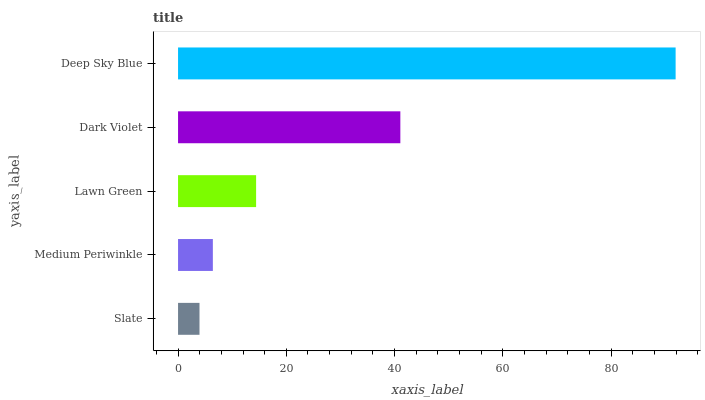Is Slate the minimum?
Answer yes or no. Yes. Is Deep Sky Blue the maximum?
Answer yes or no. Yes. Is Medium Periwinkle the minimum?
Answer yes or no. No. Is Medium Periwinkle the maximum?
Answer yes or no. No. Is Medium Periwinkle greater than Slate?
Answer yes or no. Yes. Is Slate less than Medium Periwinkle?
Answer yes or no. Yes. Is Slate greater than Medium Periwinkle?
Answer yes or no. No. Is Medium Periwinkle less than Slate?
Answer yes or no. No. Is Lawn Green the high median?
Answer yes or no. Yes. Is Lawn Green the low median?
Answer yes or no. Yes. Is Medium Periwinkle the high median?
Answer yes or no. No. Is Dark Violet the low median?
Answer yes or no. No. 